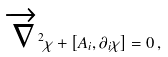Convert formula to latex. <formula><loc_0><loc_0><loc_500><loc_500>\overrightarrow { \nabla } ^ { 2 } \chi + \left [ A _ { i } , \partial _ { i } \chi \right ] = 0 \, ,</formula> 